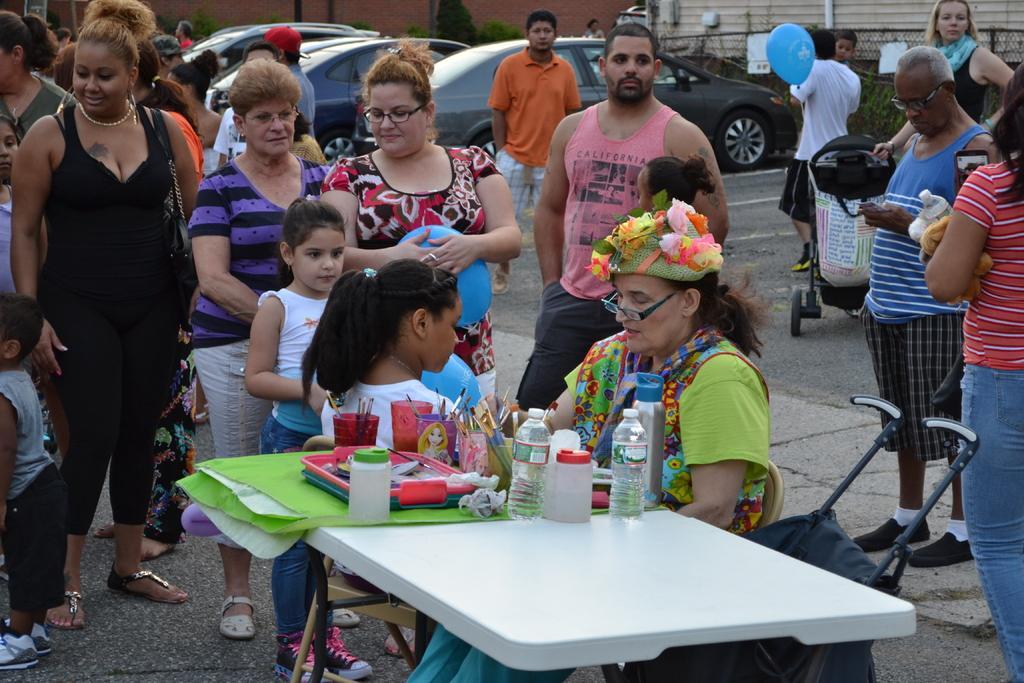Please provide a concise description of this image. In this picture we can see a woman is sitting on a chair she is wearing glasses, and in front of her a child is sitting, here is the table here is the water bottle, and a glass and brushes in it. and some tray with objects, and there is the travelling bag, and group of people standing on the road. and here is the car on the road, and there is the fencing and beside some bushes, and here is person standing with a with t-shirt holding a balloon in his hand. 